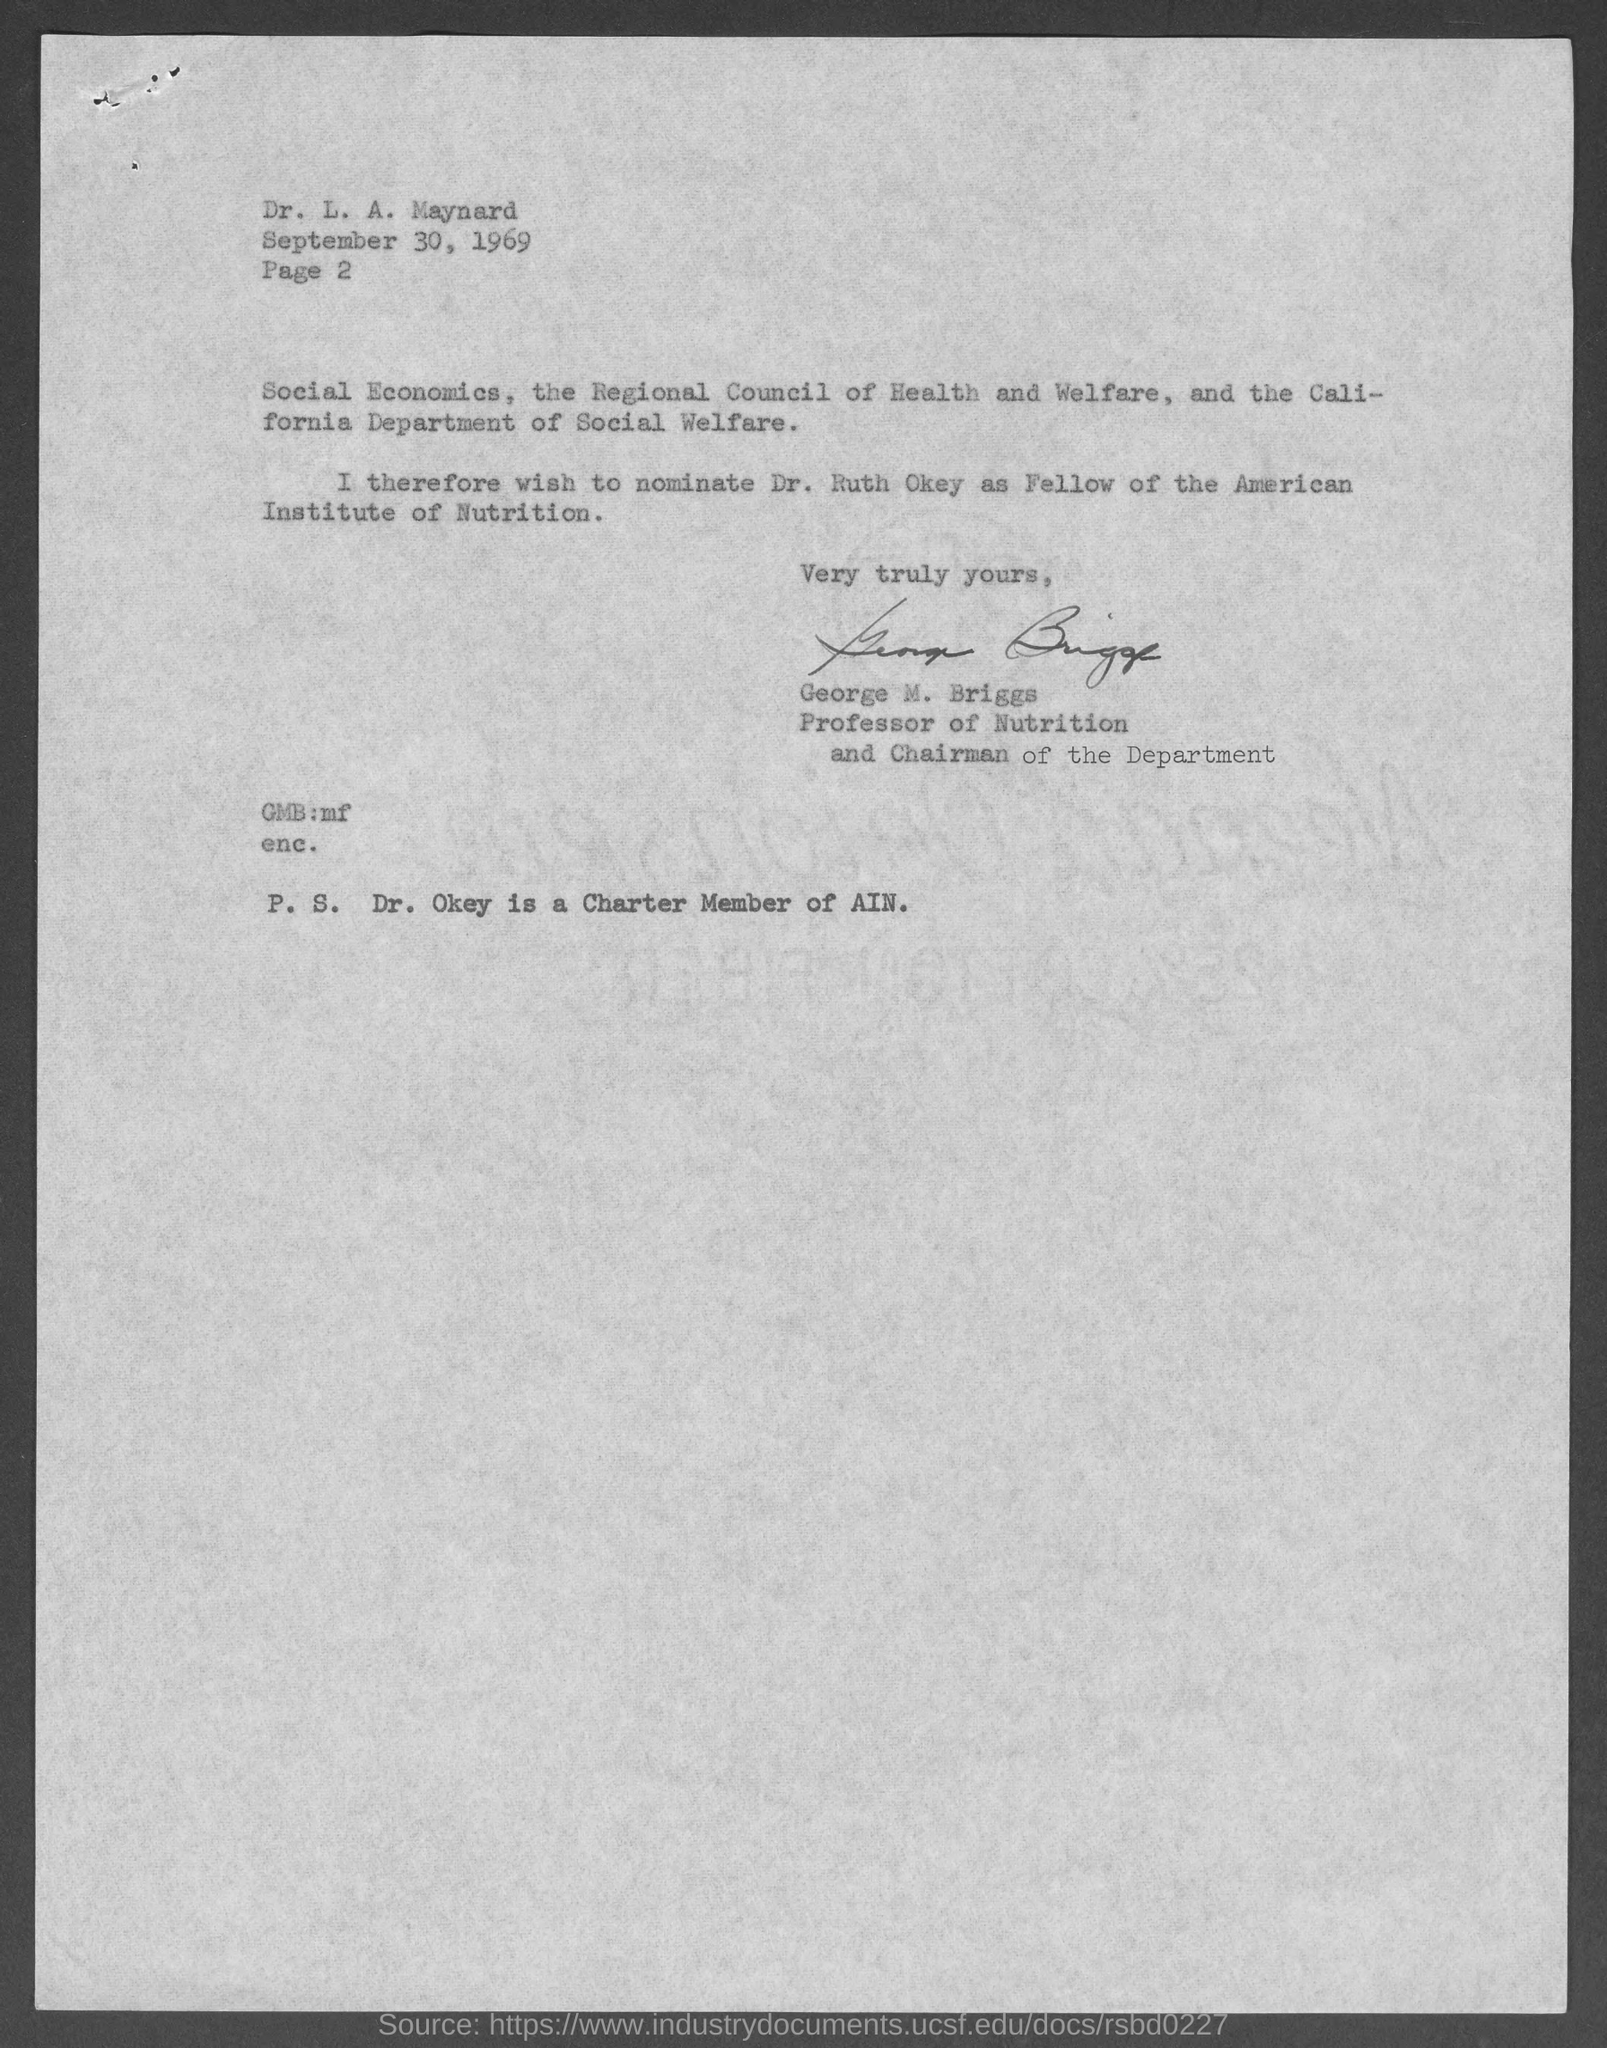List a handful of essential elements in this visual. George M. Briggs is a Professor of Nutrition and the Chairman of the Department. The letter is dated on September 30, 1969. Dr. Okey is the charter member of AIN. The page number is 2, ranging from 2... The letter is written to Dr. L. A. Maynard. 